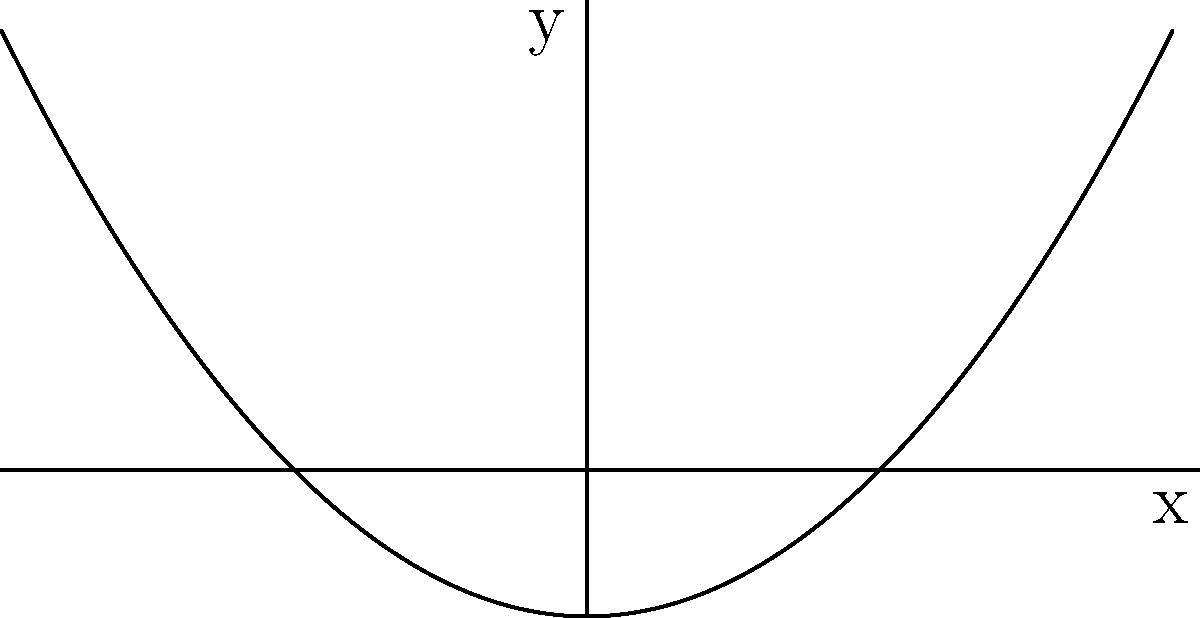As you're helping your new immigrant friend understand American high school social dynamics, you decide to use a visual analogy. You sketch a graph on a napkin at lunch and ask: "This curve represents the different social groups in our school. Can you identify what type of conic section this graph shows?" Let's analyze this step-by-step:

1) First, we need to observe the general shape of the curve. It opens upward and has a U-shape.

2) The curve intersects the y-axis at two points, which are symmetrical about the x-axis.

3) The curve extends infinitely in the positive y direction as x approaches positive or negative infinity.

4) These characteristics are typical of a parabola.

5) A parabola is defined as the set of all points in a plane that are equidistant from a fixed point (focus) and a fixed line (directrix).

6) In the context of conic sections, a parabola occurs when a plane intersects a cone parallel to one of its sides.

7) The equation of a parabola with a vertical axis of symmetry is generally of the form:

   $$(x-h)^2 = 4p(y-k)$$

   where $(h,k)$ is the vertex and $p$ is the distance from the vertex to the focus.

8) In this case, the parabola appears to have its vertex at $(0,-1)$, which aligns with the social analogy of different groups branching out from a central point.
Answer: Parabola 